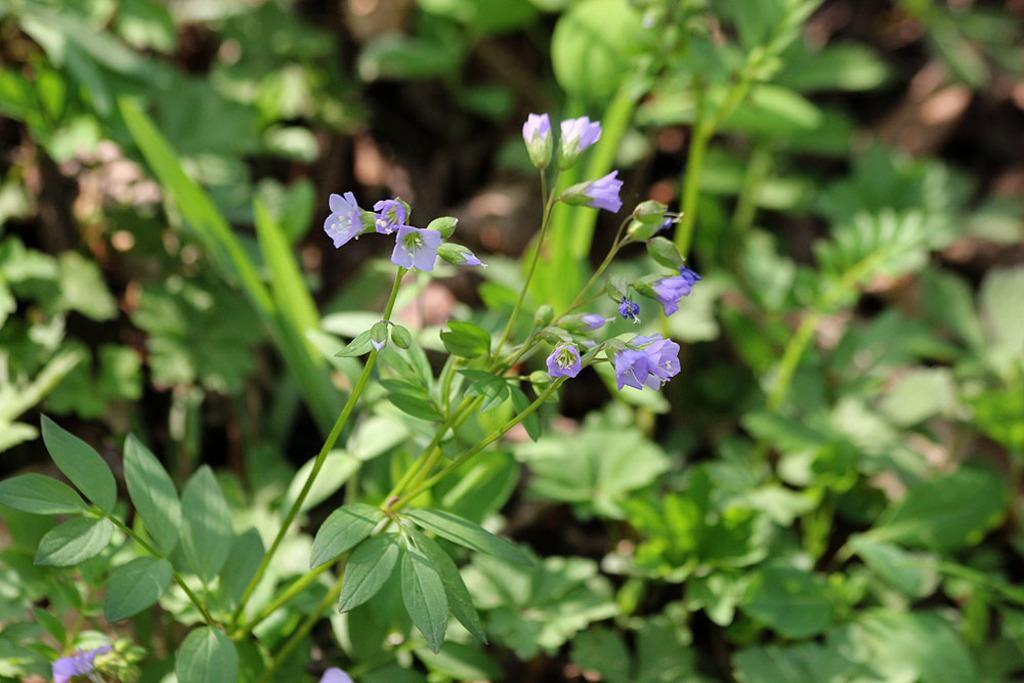What type of plant is in the foreground of the image? There is a flowering plant in the foreground of the image. What can be seen in the background of the image? There are green plants in the background of the image. What type of loaf is being served on the sofa in the image? There is no loaf or sofa present in the image; it only features plants. 